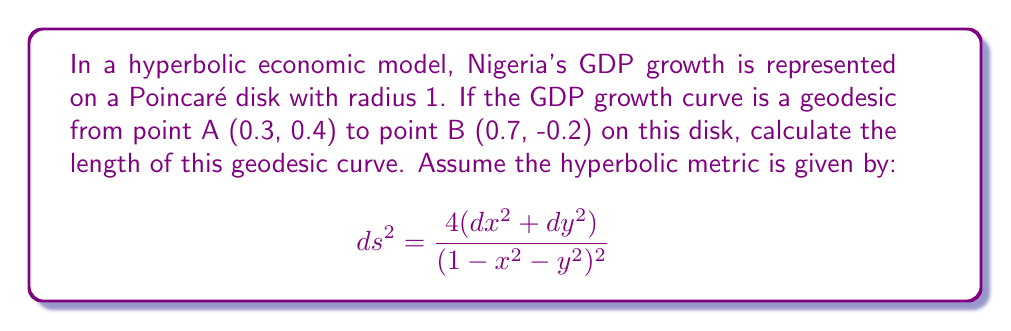Could you help me with this problem? To solve this problem, we'll follow these steps:

1) In the Poincaré disk model, geodesics are either diameters or arcs of circles perpendicular to the boundary of the disk.

2) We need to find the center and radius of the circle that passes through points A and B and is perpendicular to the unit circle.

3) The general equation of a circle perpendicular to the unit circle is:
   $$(x-a)^2 + (y-b)^2 = a^2 + b^2 - 1$$
   where (a,b) is the center of the circle.

4) Substituting the coordinates of A and B into this equation:
   $$(0.3-a)^2 + (0.4-b)^2 = a^2 + b^2 - 1$$
   $$(0.7-a)^2 + (-0.2-b)^2 = a^2 + b^2 - 1$$

5) Solving these equations simultaneously (which can be done numerically), we get:
   $a \approx 0.9325$ and $b \approx 0.3611$

6) The radius of this circle is:
   $$R = \sqrt{a^2 + b^2 - 1} \approx 0.4472$$

7) Now, we need to find the angles that A and B make with the center:
   $$\theta_A = \arctan2(0.4-0.3611, 0.3-0.9325) \approx 2.6180$$
   $$\theta_B = \arctan2(-0.2-0.3611, 0.7-0.9325) \approx -1.2490$$

8) The central angle between A and B is:
   $$|\theta_A - \theta_B| \approx 3.8670$$

9) In hyperbolic geometry, the length of an arc on the Poincaré disk is given by:
   $$L = 2 \arcsinh\left(\frac{R|\theta_A - \theta_B|}{1-R^2}\right)$$

10) Substituting our values:
    $$L = 2 \arcsinh\left(\frac{0.4472 * 3.8670}{1-0.4472^2}\right) \approx 1.9878$$

Therefore, the length of the geodesic curve representing Nigeria's GDP growth is approximately 1.9878 in hyperbolic units.
Answer: $1.9878$ hyperbolic units 